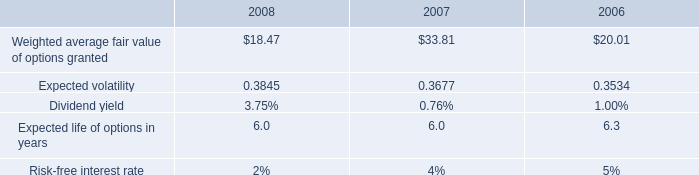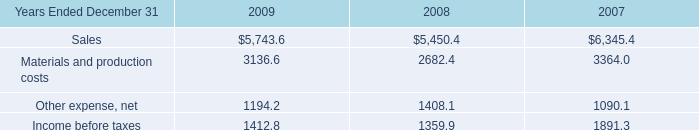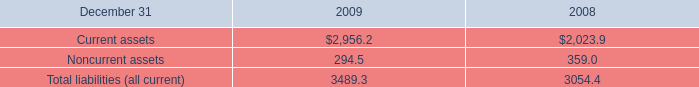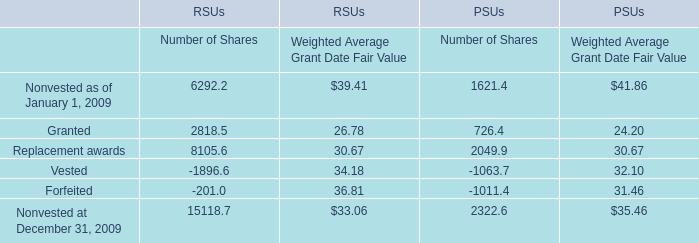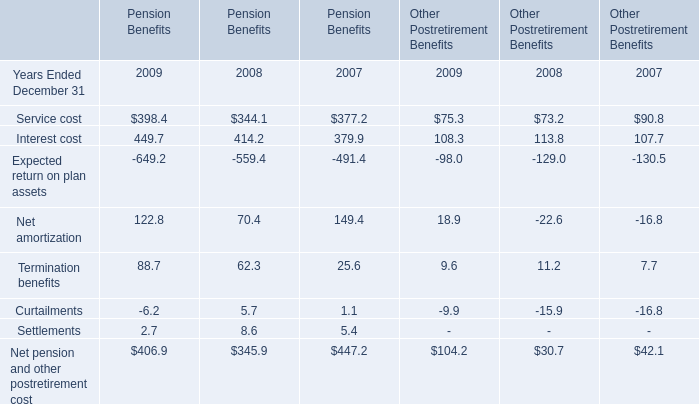In the year with the most Settlements, what is the growth rate of Curtailments for Pension Benefits? 
Computations: ((5.7 - 1.1) / 1.1)
Answer: 4.18182. 